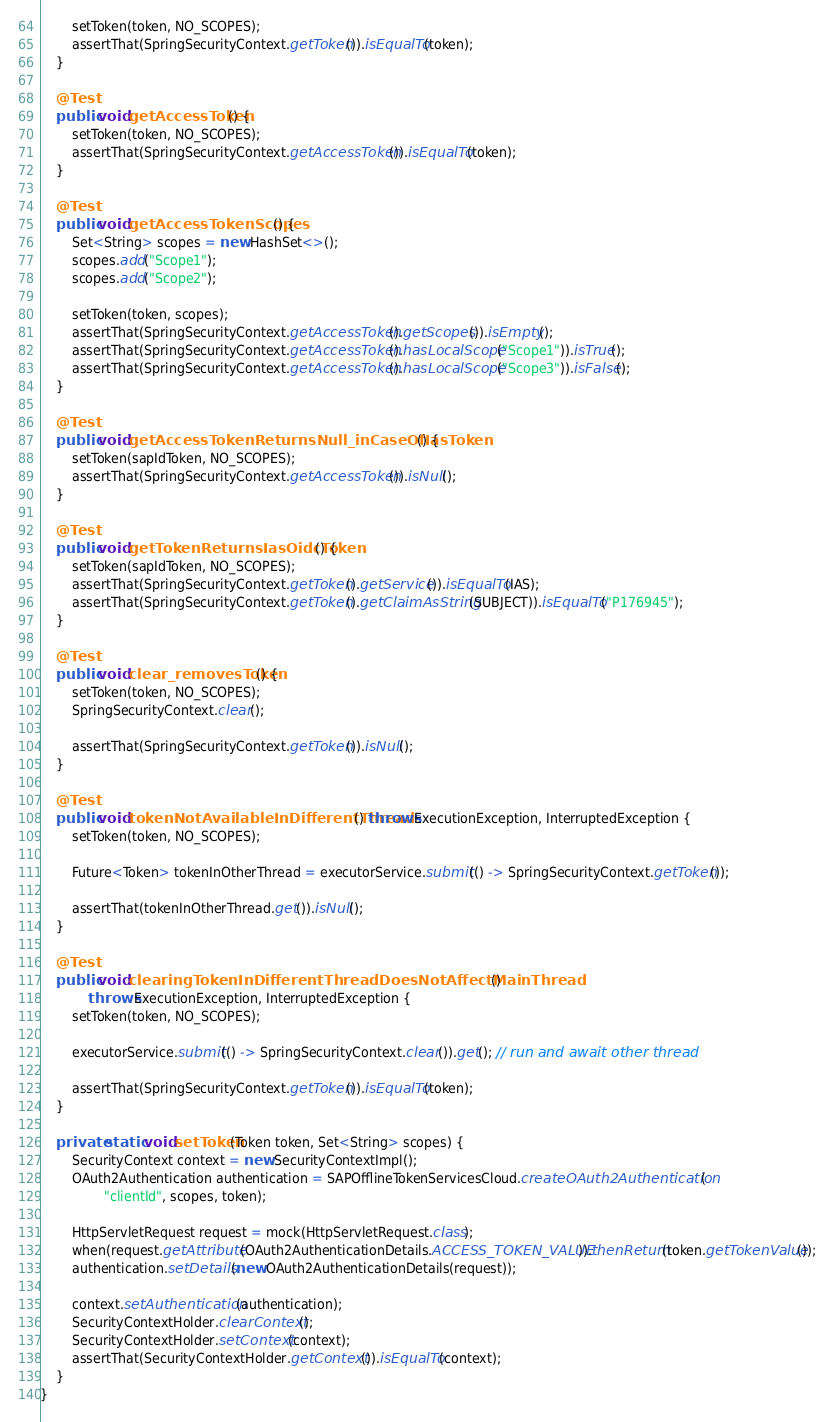<code> <loc_0><loc_0><loc_500><loc_500><_Java_>		setToken(token, NO_SCOPES);
		assertThat(SpringSecurityContext.getToken()).isEqualTo(token);
	}

	@Test
	public void getAccessToken() {
		setToken(token, NO_SCOPES);
		assertThat(SpringSecurityContext.getAccessToken()).isEqualTo(token);
	}

	@Test
	public void getAccessTokenScopes() {
		Set<String> scopes = new HashSet<>();
		scopes.add("Scope1");
		scopes.add("Scope2");

		setToken(token, scopes);
		assertThat(SpringSecurityContext.getAccessToken().getScopes()).isEmpty();
		assertThat(SpringSecurityContext.getAccessToken().hasLocalScope("Scope1")).isTrue();
		assertThat(SpringSecurityContext.getAccessToken().hasLocalScope("Scope3")).isFalse();
	}

	@Test
	public void getAccessTokenReturnsNull_inCaseOfIasToken() {
		setToken(sapIdToken, NO_SCOPES);
		assertThat(SpringSecurityContext.getAccessToken()).isNull();
	}

	@Test
	public void getTokenReturnsIasOidcToken() {
		setToken(sapIdToken, NO_SCOPES);
		assertThat(SpringSecurityContext.getToken().getService()).isEqualTo(IAS);
		assertThat(SpringSecurityContext.getToken().getClaimAsString(SUBJECT)).isEqualTo("P176945");
	}

	@Test
	public void clear_removesToken() {
		setToken(token, NO_SCOPES);
		SpringSecurityContext.clear();

		assertThat(SpringSecurityContext.getToken()).isNull();
	}

	@Test
	public void tokenNotAvailableInDifferentThread() throws ExecutionException, InterruptedException {
		setToken(token, NO_SCOPES);

		Future<Token> tokenInOtherThread = executorService.submit(() -> SpringSecurityContext.getToken());

		assertThat(tokenInOtherThread.get()).isNull();
	}

	@Test
	public void clearingTokenInDifferentThreadDoesNotAffectMainThread()
			throws ExecutionException, InterruptedException {
		setToken(token, NO_SCOPES);

		executorService.submit(() -> SpringSecurityContext.clear()).get(); // run and await other thread

		assertThat(SpringSecurityContext.getToken()).isEqualTo(token);
	}

	private static void setToken(Token token, Set<String> scopes) {
		SecurityContext context = new SecurityContextImpl();
		OAuth2Authentication authentication = SAPOfflineTokenServicesCloud.createOAuth2Authentication(
				"clientId", scopes, token);

		HttpServletRequest request = mock(HttpServletRequest.class);
		when(request.getAttribute(OAuth2AuthenticationDetails.ACCESS_TOKEN_VALUE)).thenReturn(token.getTokenValue());
		authentication.setDetails(new OAuth2AuthenticationDetails(request));

		context.setAuthentication(authentication);
		SecurityContextHolder.clearContext();
		SecurityContextHolder.setContext(context);
		assertThat(SecurityContextHolder.getContext()).isEqualTo(context);
	}
}
</code> 